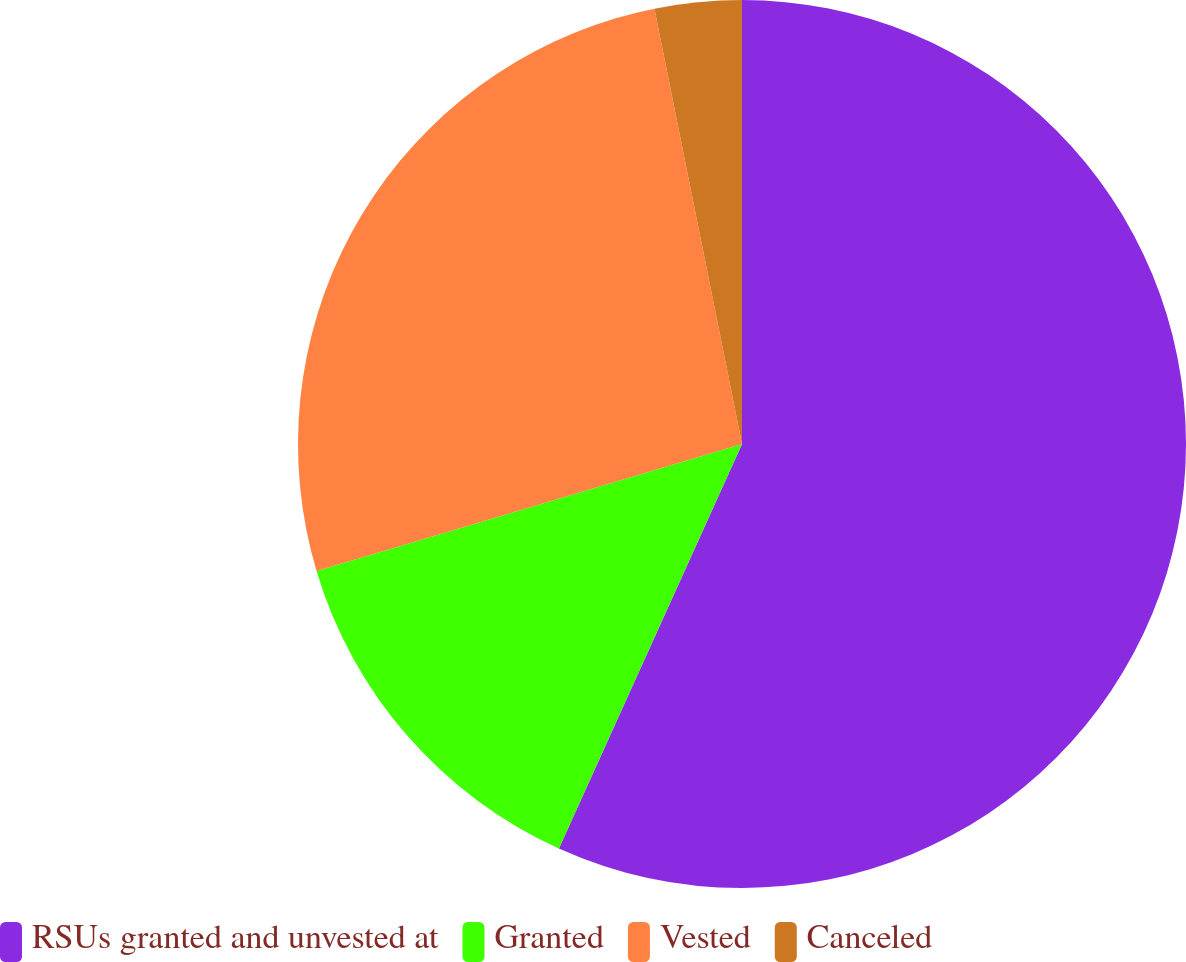Convert chart to OTSL. <chart><loc_0><loc_0><loc_500><loc_500><pie_chart><fcel>RSUs granted and unvested at<fcel>Granted<fcel>Vested<fcel>Canceled<nl><fcel>56.77%<fcel>13.62%<fcel>26.46%<fcel>3.16%<nl></chart> 